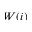Convert formula to latex. <formula><loc_0><loc_0><loc_500><loc_500>W ( i )</formula> 